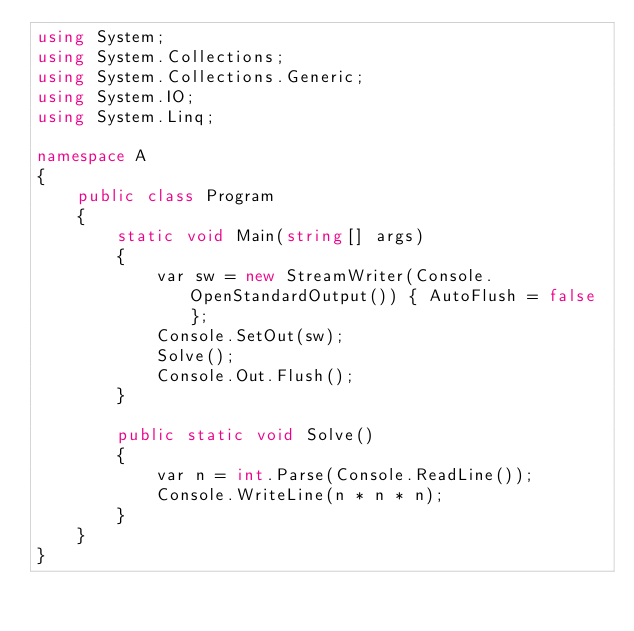Convert code to text. <code><loc_0><loc_0><loc_500><loc_500><_C#_>using System;
using System.Collections;
using System.Collections.Generic;
using System.IO;
using System.Linq;

namespace A
{
    public class Program
    {
        static void Main(string[] args)
        {
            var sw = new StreamWriter(Console.OpenStandardOutput()) { AutoFlush = false };
            Console.SetOut(sw);
            Solve();
            Console.Out.Flush();
        }

        public static void Solve()
        {
            var n = int.Parse(Console.ReadLine());
            Console.WriteLine(n * n * n);
        }
    }
}
</code> 